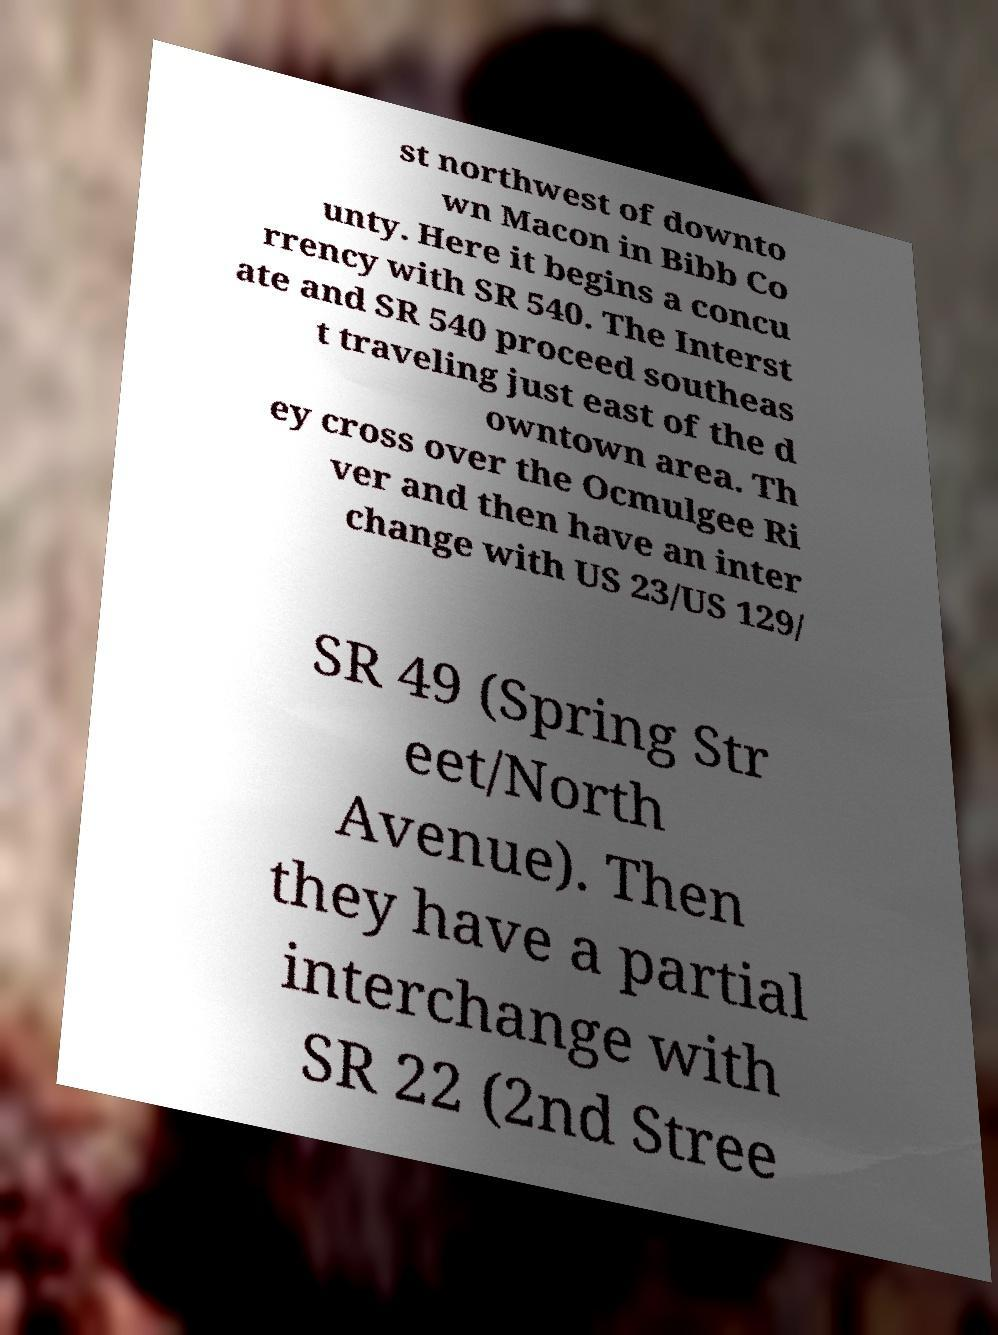Please identify and transcribe the text found in this image. st northwest of downto wn Macon in Bibb Co unty. Here it begins a concu rrency with SR 540. The Interst ate and SR 540 proceed southeas t traveling just east of the d owntown area. Th ey cross over the Ocmulgee Ri ver and then have an inter change with US 23/US 129/ SR 49 (Spring Str eet/North Avenue). Then they have a partial interchange with SR 22 (2nd Stree 